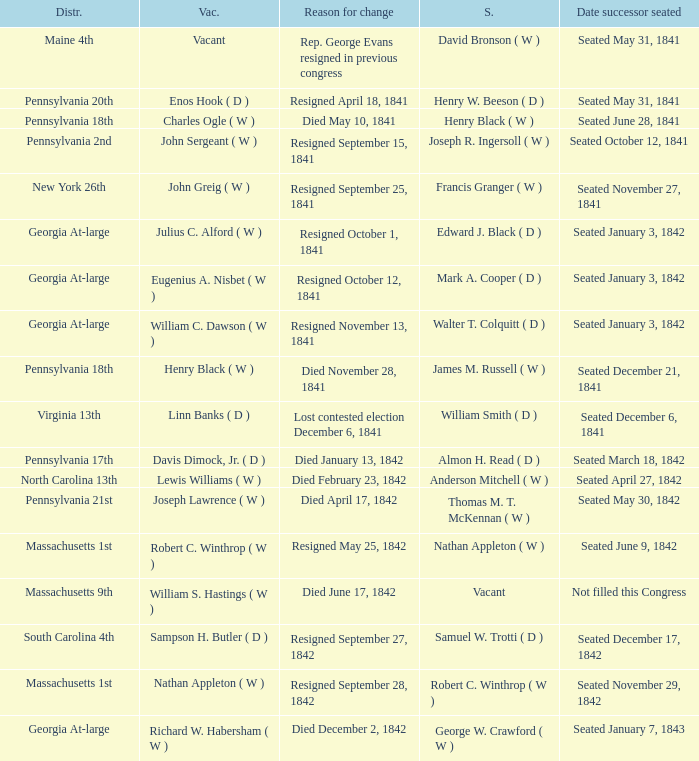Name the successor for north carolina 13th Anderson Mitchell ( W ). 